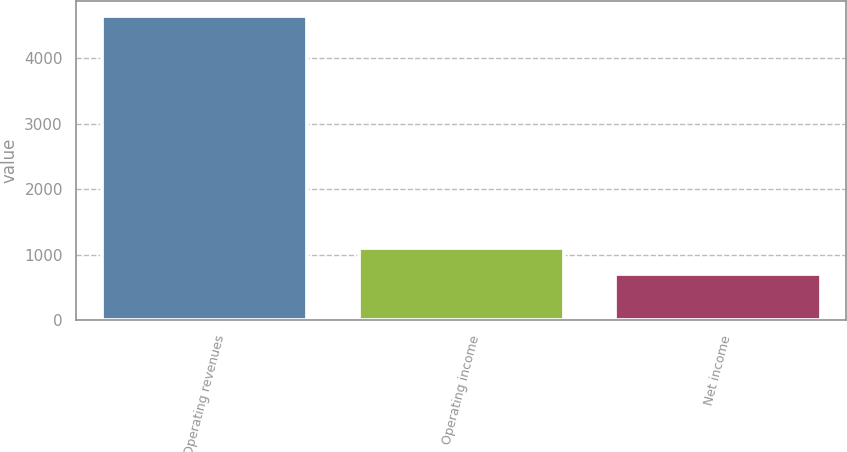Convert chart to OTSL. <chart><loc_0><loc_0><loc_500><loc_500><bar_chart><fcel>Operating revenues<fcel>Operating income<fcel>Net income<nl><fcel>4646<fcel>1105.4<fcel>712<nl></chart> 